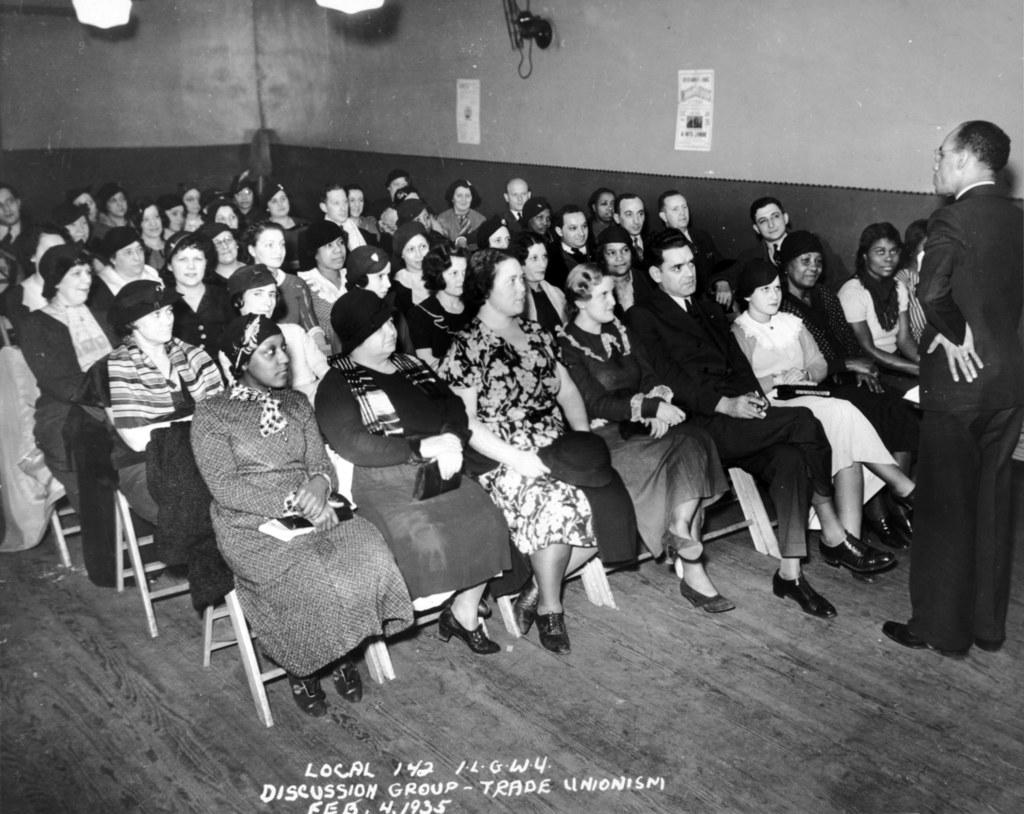How many people are sitting on the chair in the image? There is a group of people sitting on a chair in the image. What is happening in the background of the image? There is a man standing in the background, and there is a wall and a paper visible. What is the source of light in the image? There is a light at the top of the image. What type of patch is being sewn onto the man's mouth in the image? There is no man with a patch on his mouth in the image. 